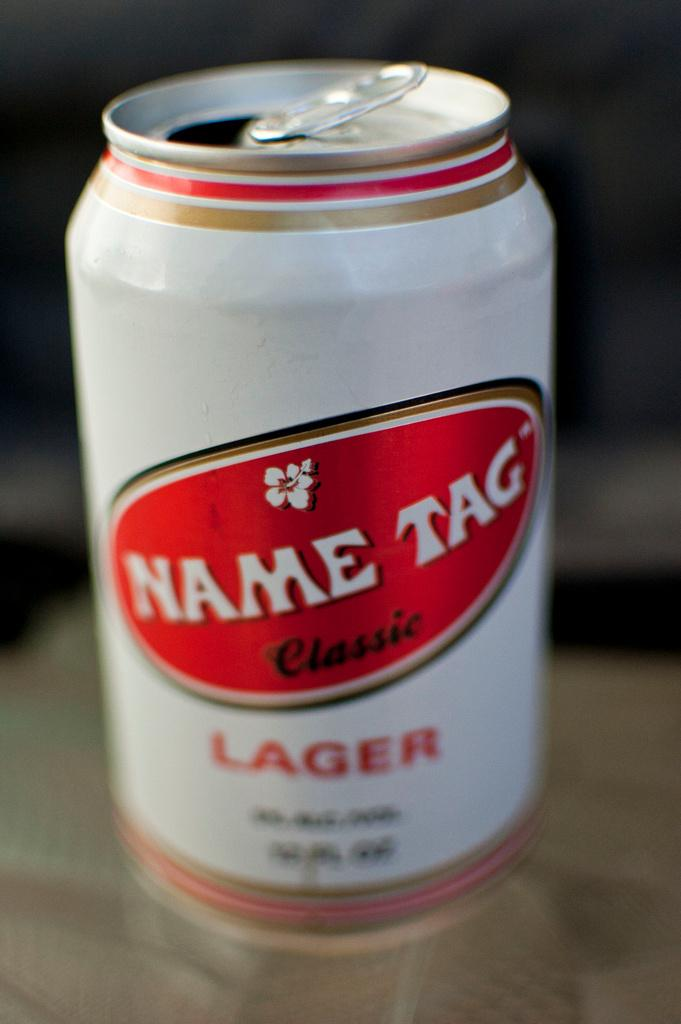Provide a one-sentence caption for the provided image. A can of beer called Name Tag Classic has been opened. 